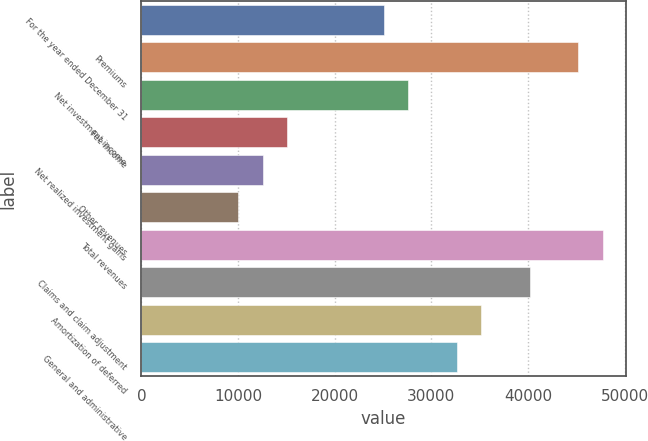Convert chart to OTSL. <chart><loc_0><loc_0><loc_500><loc_500><bar_chart><fcel>For the year ended December 31<fcel>Premiums<fcel>Net investment income<fcel>Fee income<fcel>Net realized investment gains<fcel>Other revenues<fcel>Total revenues<fcel>Claims and claim adjustment<fcel>Amortization of deferred<fcel>General and administrative<nl><fcel>25112<fcel>45196.3<fcel>27622.6<fcel>15069.9<fcel>12559.3<fcel>10048.8<fcel>47706.9<fcel>40175.3<fcel>35154.2<fcel>32643.6<nl></chart> 